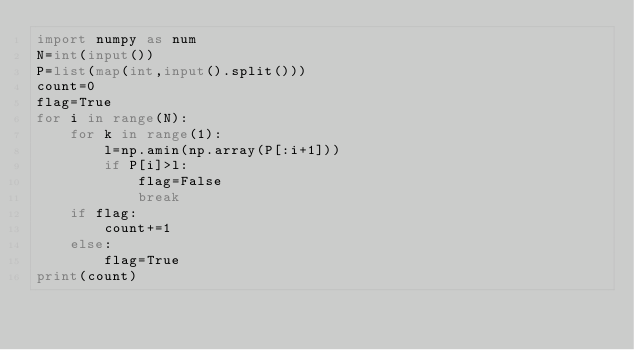<code> <loc_0><loc_0><loc_500><loc_500><_Python_>import numpy as num
N=int(input())
P=list(map(int,input().split()))
count=0
flag=True
for i in range(N):
    for k in range(1):
        l=np.amin(np.array(P[:i+1]))
        if P[i]>l:
            flag=False
            break
    if flag:
        count+=1
    else:
        flag=True
print(count)</code> 